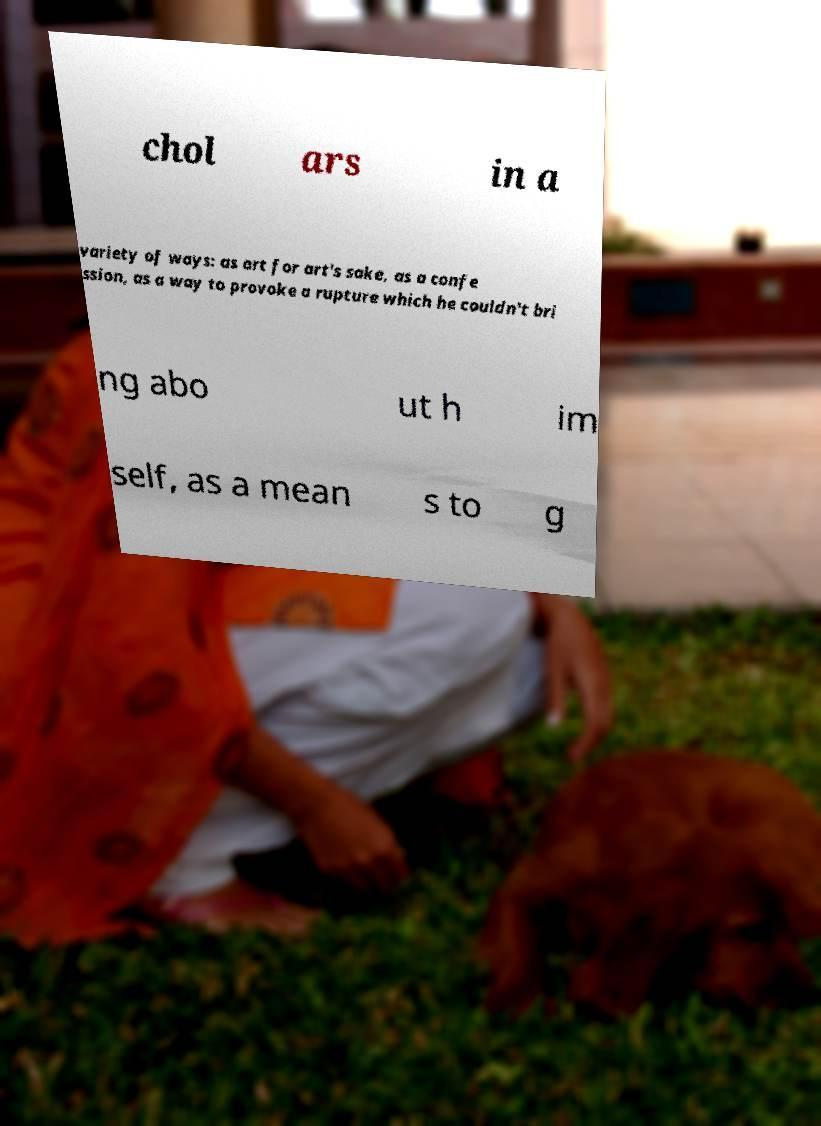Can you accurately transcribe the text from the provided image for me? chol ars in a variety of ways: as art for art's sake, as a confe ssion, as a way to provoke a rupture which he couldn't bri ng abo ut h im self, as a mean s to g 